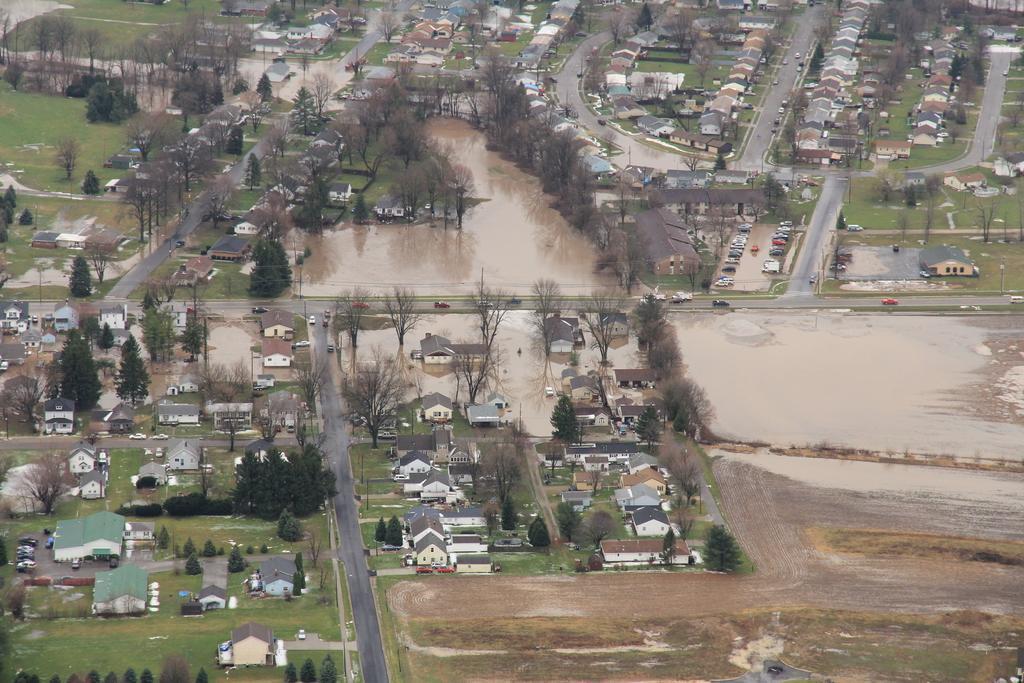Can you describe this image briefly? In this picture we can observe houses. There are roads. We can observe water in between the houses and there are some vehicles moving on the roads. There are trees in this picture. 